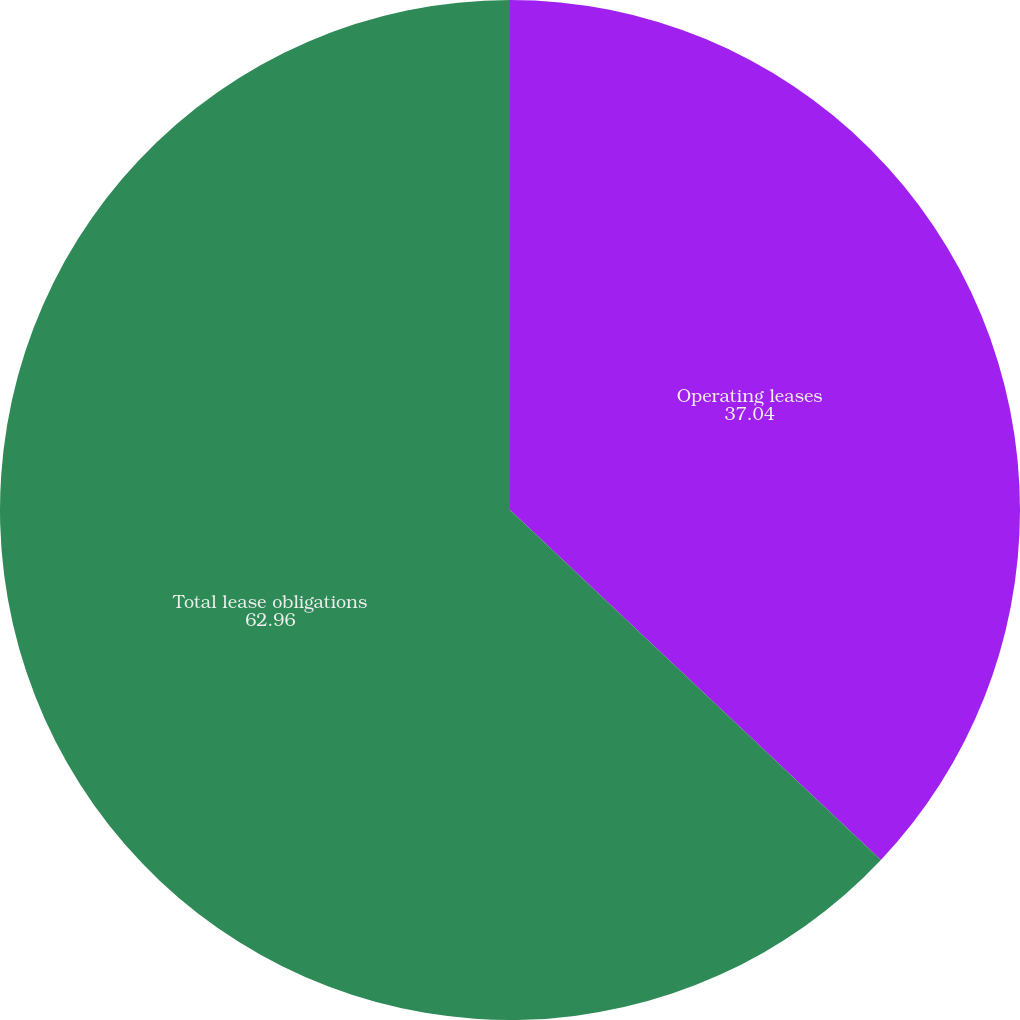<chart> <loc_0><loc_0><loc_500><loc_500><pie_chart><fcel>Operating leases<fcel>Total lease obligations<nl><fcel>37.04%<fcel>62.96%<nl></chart> 